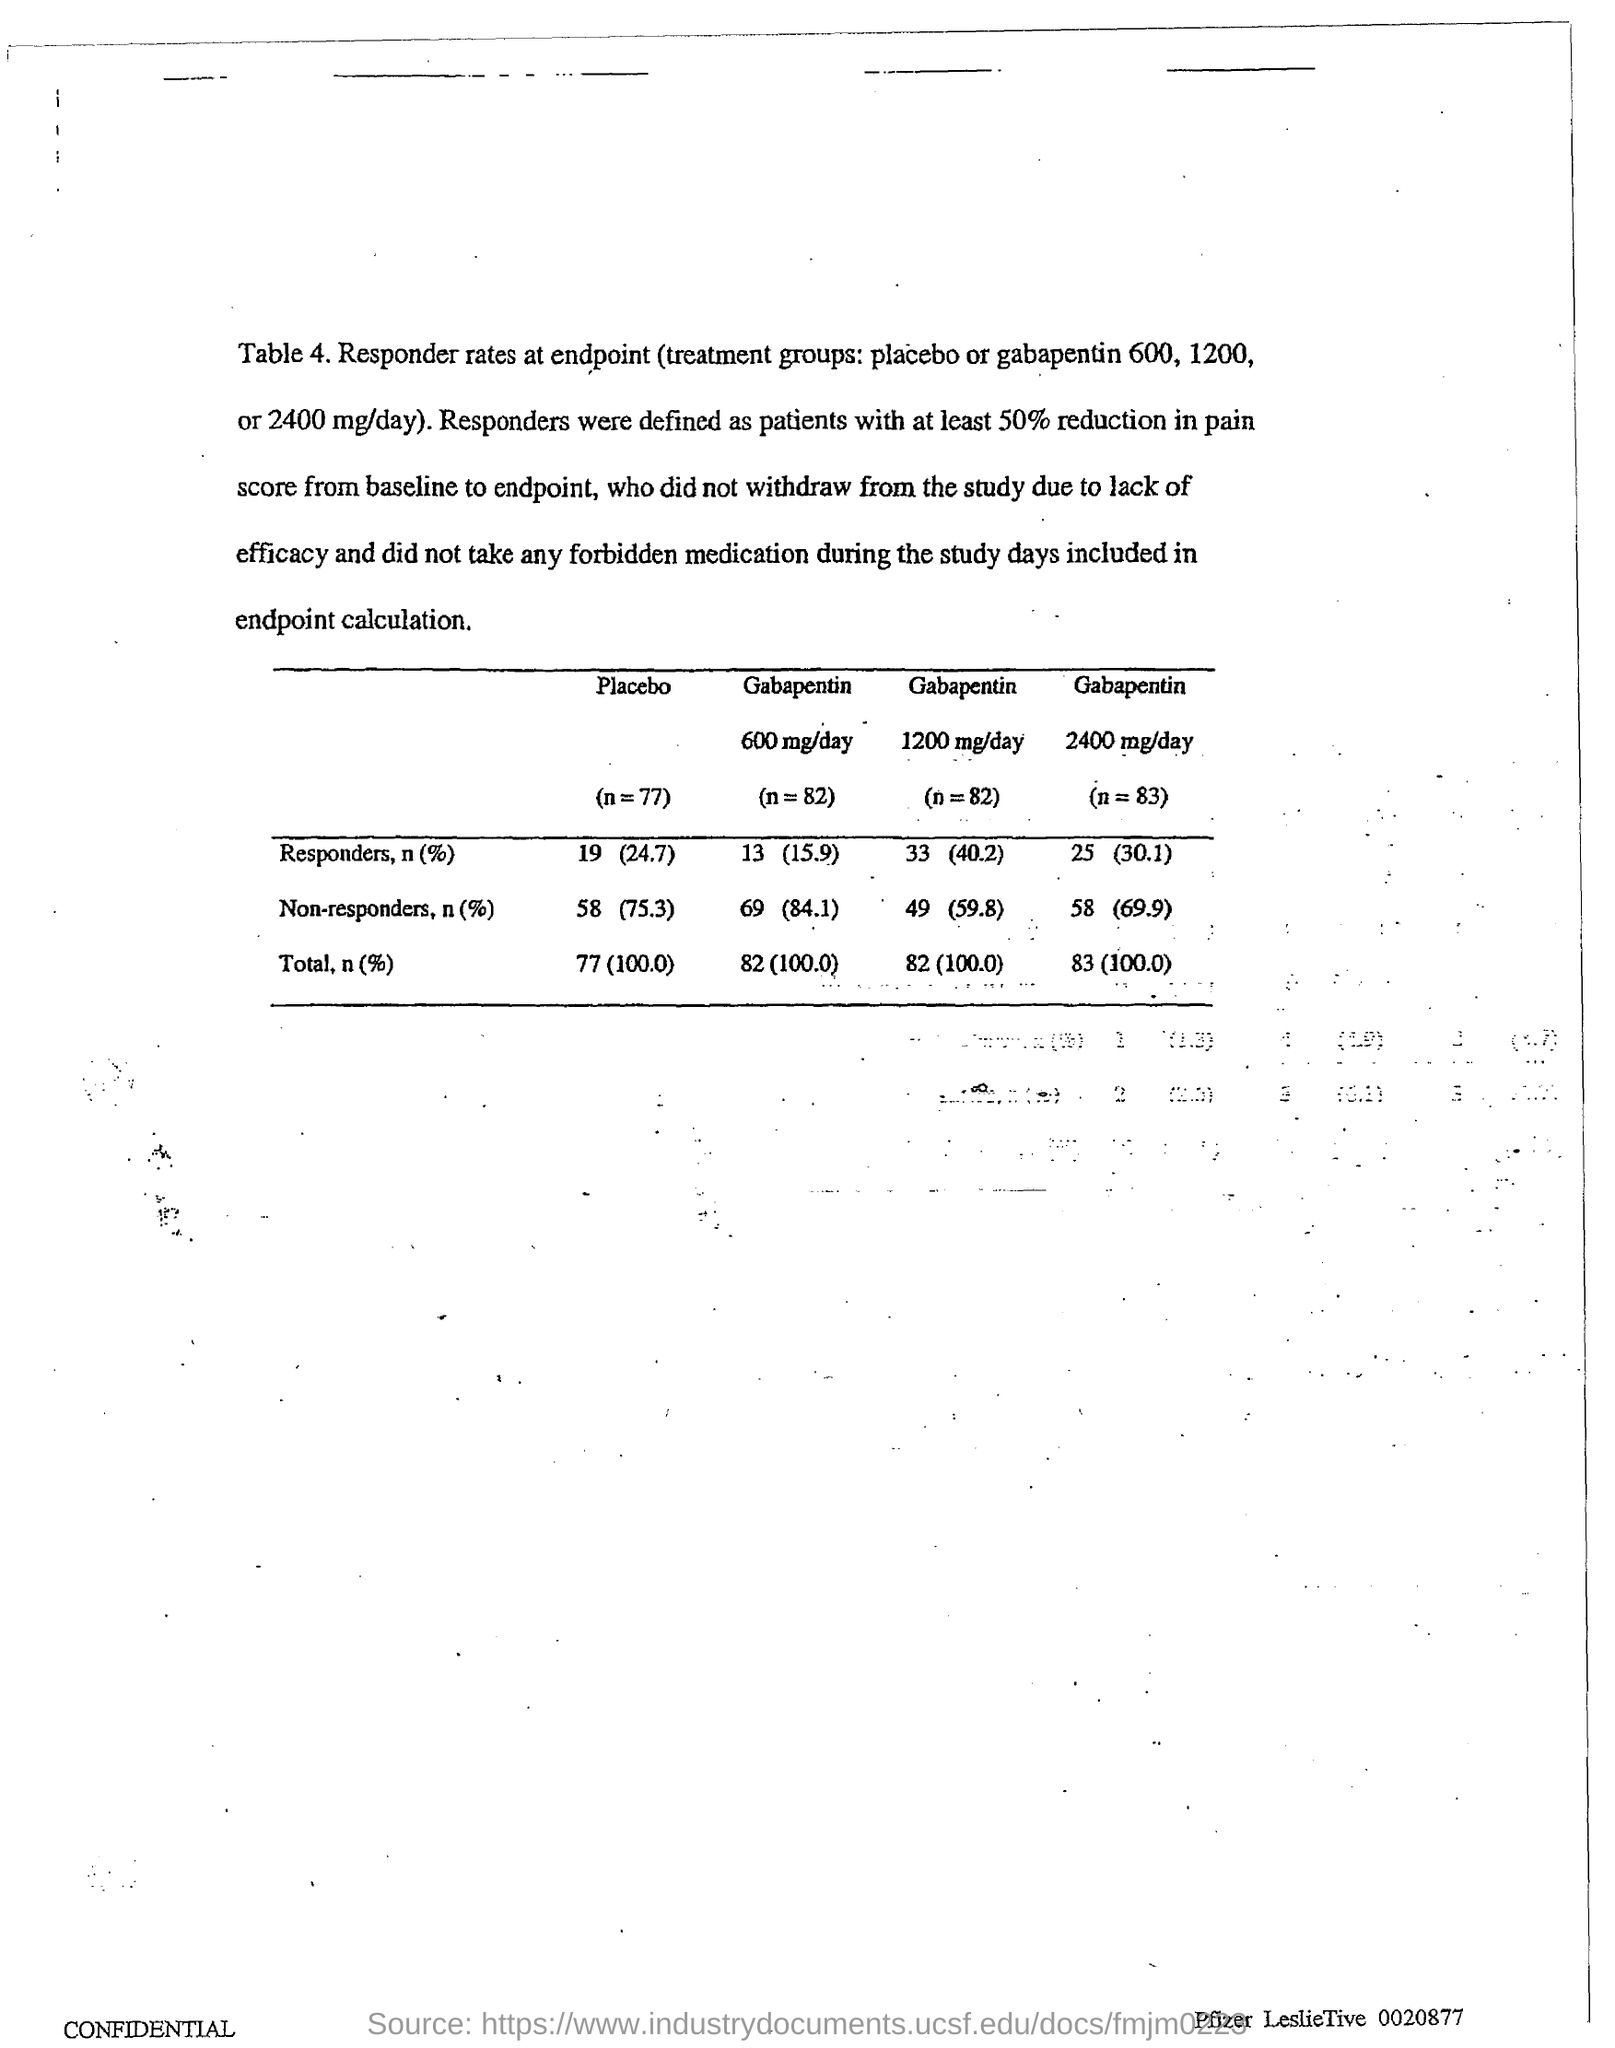What is the responders,n(%) in placebo
Provide a short and direct response. 19 (24.7). What is the non responders,n(%) in gabapentin 600 mg/day
Your answer should be very brief. 69 (84.1). What is the total,n(%) in gabapentin 1200 mg/day
Ensure brevity in your answer.  82 (100.0). What is the non responders,n(%) in gabapentin 2400 mg/day
Ensure brevity in your answer.  58 (69.9). 